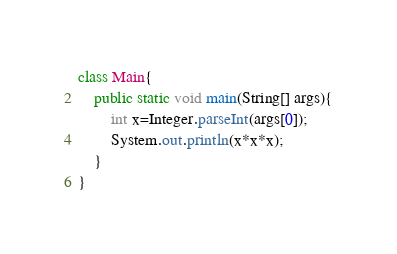<code> <loc_0><loc_0><loc_500><loc_500><_Java_>class Main{
	public static void main(String[] args){
		int x=Integer.parseInt(args[0]);
		System.out.println(x*x*x);
	}
}</code> 